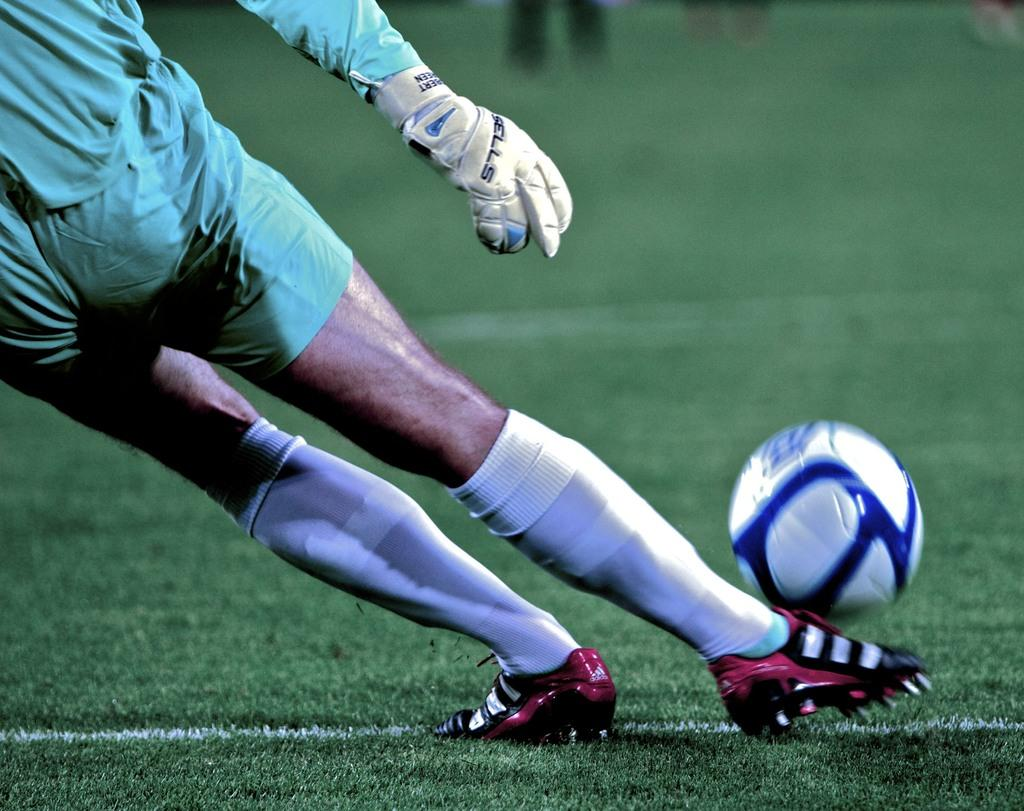Who is present in the image? There is a person in the image. What is the person doing in the image? The person is about to hit a football. What type of surface is visible at the bottom of the image? There is grass on the surface at the bottom of the image. What type of wax can be seen melting in the image? There is no wax present in the image. What rhythm is the person playing on the football in the image? The image does not depict any rhythm or musical element; the person is simply about to hit a football. 